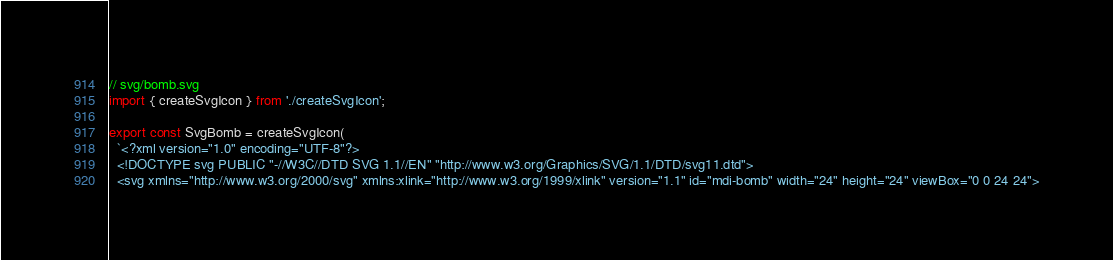Convert code to text. <code><loc_0><loc_0><loc_500><loc_500><_TypeScript_>// svg/bomb.svg
import { createSvgIcon } from './createSvgIcon';

export const SvgBomb = createSvgIcon(
  `<?xml version="1.0" encoding="UTF-8"?>
  <!DOCTYPE svg PUBLIC "-//W3C//DTD SVG 1.1//EN" "http://www.w3.org/Graphics/SVG/1.1/DTD/svg11.dtd">
  <svg xmlns="http://www.w3.org/2000/svg" xmlns:xlink="http://www.w3.org/1999/xlink" version="1.1" id="mdi-bomb" width="24" height="24" viewBox="0 0 24 24"></code> 